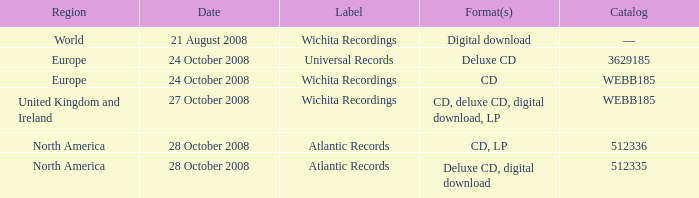What are the formats associated with the Atlantic Records label, catalog number 512336? CD, LP. 